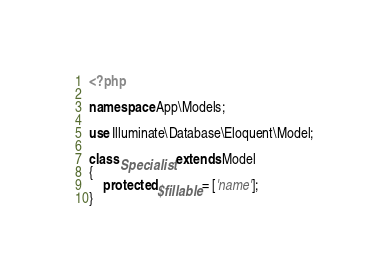Convert code to text. <code><loc_0><loc_0><loc_500><loc_500><_PHP_><?php

namespace App\Models;

use Illuminate\Database\Eloquent\Model;

class Specialist extends Model
{
    protected $fillable = ['name'];
}
</code> 